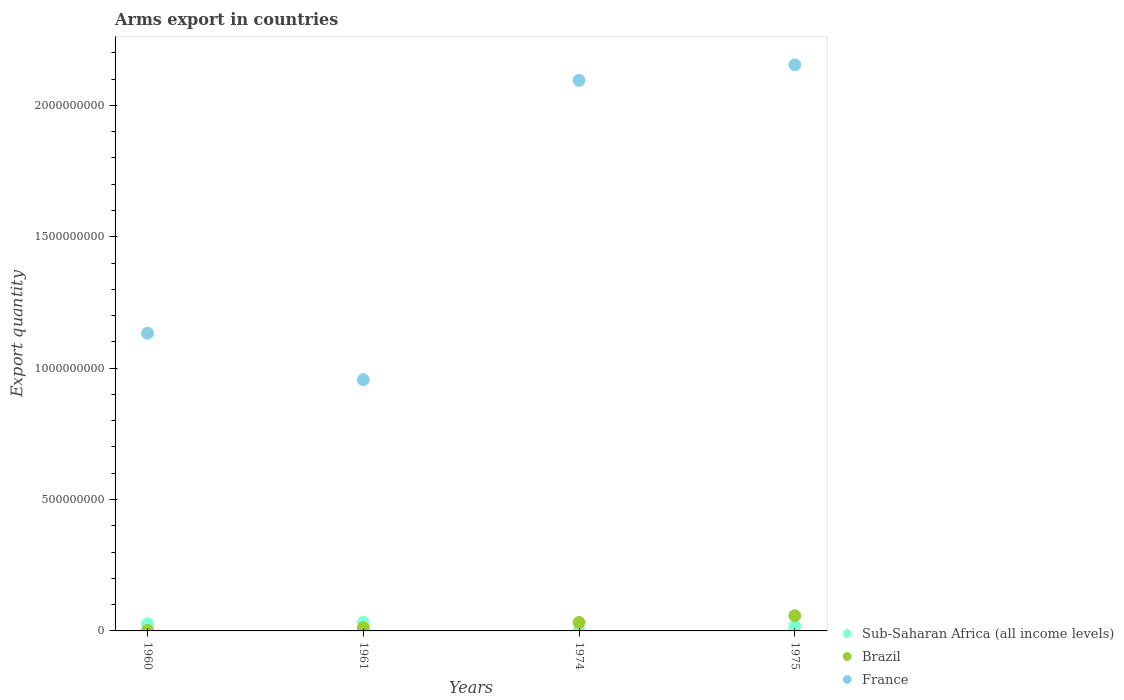How many different coloured dotlines are there?
Offer a very short reply. 3. Is the number of dotlines equal to the number of legend labels?
Keep it short and to the point. Yes. What is the total arms export in Brazil in 1974?
Your response must be concise. 3.20e+07. Across all years, what is the maximum total arms export in Sub-Saharan Africa (all income levels)?
Make the answer very short. 3.30e+07. Across all years, what is the minimum total arms export in France?
Provide a short and direct response. 9.56e+08. In which year was the total arms export in Sub-Saharan Africa (all income levels) maximum?
Your answer should be very brief. 1961. In which year was the total arms export in Sub-Saharan Africa (all income levels) minimum?
Make the answer very short. 1974. What is the total total arms export in Brazil in the graph?
Make the answer very short. 1.04e+08. What is the difference between the total arms export in France in 1960 and that in 1975?
Make the answer very short. -1.02e+09. What is the difference between the total arms export in Sub-Saharan Africa (all income levels) in 1960 and the total arms export in France in 1974?
Offer a very short reply. -2.07e+09. What is the average total arms export in France per year?
Your answer should be very brief. 1.58e+09. In the year 1974, what is the difference between the total arms export in France and total arms export in Sub-Saharan Africa (all income levels)?
Your response must be concise. 2.09e+09. In how many years, is the total arms export in Brazil greater than 500000000?
Offer a very short reply. 0. What is the ratio of the total arms export in Brazil in 1960 to that in 1974?
Give a very brief answer. 0.06. What is the difference between the highest and the second highest total arms export in Brazil?
Provide a short and direct response. 2.60e+07. What is the difference between the highest and the lowest total arms export in Sub-Saharan Africa (all income levels)?
Your answer should be compact. 3.10e+07. Is the sum of the total arms export in France in 1960 and 1961 greater than the maximum total arms export in Brazil across all years?
Provide a short and direct response. Yes. Does the total arms export in Brazil monotonically increase over the years?
Your answer should be compact. Yes. Is the total arms export in Brazil strictly greater than the total arms export in Sub-Saharan Africa (all income levels) over the years?
Your answer should be compact. No. How many dotlines are there?
Ensure brevity in your answer.  3. How many years are there in the graph?
Make the answer very short. 4. What is the difference between two consecutive major ticks on the Y-axis?
Keep it short and to the point. 5.00e+08. Does the graph contain any zero values?
Provide a succinct answer. No. Where does the legend appear in the graph?
Give a very brief answer. Bottom right. How are the legend labels stacked?
Your response must be concise. Vertical. What is the title of the graph?
Your answer should be very brief. Arms export in countries. Does "Paraguay" appear as one of the legend labels in the graph?
Keep it short and to the point. No. What is the label or title of the X-axis?
Provide a short and direct response. Years. What is the label or title of the Y-axis?
Provide a short and direct response. Export quantity. What is the Export quantity of Sub-Saharan Africa (all income levels) in 1960?
Provide a succinct answer. 2.70e+07. What is the Export quantity in Brazil in 1960?
Provide a succinct answer. 2.00e+06. What is the Export quantity of France in 1960?
Give a very brief answer. 1.13e+09. What is the Export quantity of Sub-Saharan Africa (all income levels) in 1961?
Your answer should be compact. 3.30e+07. What is the Export quantity of France in 1961?
Provide a succinct answer. 9.56e+08. What is the Export quantity of Sub-Saharan Africa (all income levels) in 1974?
Keep it short and to the point. 2.00e+06. What is the Export quantity in Brazil in 1974?
Give a very brief answer. 3.20e+07. What is the Export quantity in France in 1974?
Provide a short and direct response. 2.10e+09. What is the Export quantity of Sub-Saharan Africa (all income levels) in 1975?
Your answer should be very brief. 1.80e+07. What is the Export quantity in Brazil in 1975?
Provide a short and direct response. 5.80e+07. What is the Export quantity in France in 1975?
Your answer should be compact. 2.15e+09. Across all years, what is the maximum Export quantity in Sub-Saharan Africa (all income levels)?
Give a very brief answer. 3.30e+07. Across all years, what is the maximum Export quantity of Brazil?
Provide a short and direct response. 5.80e+07. Across all years, what is the maximum Export quantity in France?
Make the answer very short. 2.15e+09. Across all years, what is the minimum Export quantity in Sub-Saharan Africa (all income levels)?
Give a very brief answer. 2.00e+06. Across all years, what is the minimum Export quantity of Brazil?
Offer a terse response. 2.00e+06. Across all years, what is the minimum Export quantity of France?
Keep it short and to the point. 9.56e+08. What is the total Export quantity of Sub-Saharan Africa (all income levels) in the graph?
Provide a short and direct response. 8.00e+07. What is the total Export quantity of Brazil in the graph?
Your response must be concise. 1.04e+08. What is the total Export quantity of France in the graph?
Ensure brevity in your answer.  6.34e+09. What is the difference between the Export quantity in Sub-Saharan Africa (all income levels) in 1960 and that in 1961?
Your answer should be compact. -6.00e+06. What is the difference between the Export quantity in Brazil in 1960 and that in 1961?
Provide a short and direct response. -1.00e+07. What is the difference between the Export quantity of France in 1960 and that in 1961?
Your response must be concise. 1.77e+08. What is the difference between the Export quantity in Sub-Saharan Africa (all income levels) in 1960 and that in 1974?
Offer a very short reply. 2.50e+07. What is the difference between the Export quantity of Brazil in 1960 and that in 1974?
Your response must be concise. -3.00e+07. What is the difference between the Export quantity of France in 1960 and that in 1974?
Keep it short and to the point. -9.62e+08. What is the difference between the Export quantity in Sub-Saharan Africa (all income levels) in 1960 and that in 1975?
Give a very brief answer. 9.00e+06. What is the difference between the Export quantity of Brazil in 1960 and that in 1975?
Your answer should be compact. -5.60e+07. What is the difference between the Export quantity of France in 1960 and that in 1975?
Provide a succinct answer. -1.02e+09. What is the difference between the Export quantity of Sub-Saharan Africa (all income levels) in 1961 and that in 1974?
Offer a terse response. 3.10e+07. What is the difference between the Export quantity in Brazil in 1961 and that in 1974?
Your response must be concise. -2.00e+07. What is the difference between the Export quantity in France in 1961 and that in 1974?
Give a very brief answer. -1.14e+09. What is the difference between the Export quantity of Sub-Saharan Africa (all income levels) in 1961 and that in 1975?
Ensure brevity in your answer.  1.50e+07. What is the difference between the Export quantity of Brazil in 1961 and that in 1975?
Offer a very short reply. -4.60e+07. What is the difference between the Export quantity of France in 1961 and that in 1975?
Keep it short and to the point. -1.20e+09. What is the difference between the Export quantity in Sub-Saharan Africa (all income levels) in 1974 and that in 1975?
Your answer should be very brief. -1.60e+07. What is the difference between the Export quantity in Brazil in 1974 and that in 1975?
Ensure brevity in your answer.  -2.60e+07. What is the difference between the Export quantity in France in 1974 and that in 1975?
Make the answer very short. -5.90e+07. What is the difference between the Export quantity in Sub-Saharan Africa (all income levels) in 1960 and the Export quantity in Brazil in 1961?
Give a very brief answer. 1.50e+07. What is the difference between the Export quantity in Sub-Saharan Africa (all income levels) in 1960 and the Export quantity in France in 1961?
Provide a short and direct response. -9.29e+08. What is the difference between the Export quantity in Brazil in 1960 and the Export quantity in France in 1961?
Offer a very short reply. -9.54e+08. What is the difference between the Export quantity in Sub-Saharan Africa (all income levels) in 1960 and the Export quantity in Brazil in 1974?
Your answer should be compact. -5.00e+06. What is the difference between the Export quantity of Sub-Saharan Africa (all income levels) in 1960 and the Export quantity of France in 1974?
Make the answer very short. -2.07e+09. What is the difference between the Export quantity in Brazil in 1960 and the Export quantity in France in 1974?
Make the answer very short. -2.09e+09. What is the difference between the Export quantity of Sub-Saharan Africa (all income levels) in 1960 and the Export quantity of Brazil in 1975?
Provide a succinct answer. -3.10e+07. What is the difference between the Export quantity in Sub-Saharan Africa (all income levels) in 1960 and the Export quantity in France in 1975?
Keep it short and to the point. -2.13e+09. What is the difference between the Export quantity in Brazil in 1960 and the Export quantity in France in 1975?
Provide a succinct answer. -2.15e+09. What is the difference between the Export quantity in Sub-Saharan Africa (all income levels) in 1961 and the Export quantity in Brazil in 1974?
Your response must be concise. 1.00e+06. What is the difference between the Export quantity in Sub-Saharan Africa (all income levels) in 1961 and the Export quantity in France in 1974?
Ensure brevity in your answer.  -2.06e+09. What is the difference between the Export quantity of Brazil in 1961 and the Export quantity of France in 1974?
Provide a succinct answer. -2.08e+09. What is the difference between the Export quantity in Sub-Saharan Africa (all income levels) in 1961 and the Export quantity in Brazil in 1975?
Provide a succinct answer. -2.50e+07. What is the difference between the Export quantity of Sub-Saharan Africa (all income levels) in 1961 and the Export quantity of France in 1975?
Offer a terse response. -2.12e+09. What is the difference between the Export quantity in Brazil in 1961 and the Export quantity in France in 1975?
Provide a succinct answer. -2.14e+09. What is the difference between the Export quantity of Sub-Saharan Africa (all income levels) in 1974 and the Export quantity of Brazil in 1975?
Provide a short and direct response. -5.60e+07. What is the difference between the Export quantity of Sub-Saharan Africa (all income levels) in 1974 and the Export quantity of France in 1975?
Make the answer very short. -2.15e+09. What is the difference between the Export quantity in Brazil in 1974 and the Export quantity in France in 1975?
Make the answer very short. -2.12e+09. What is the average Export quantity in Brazil per year?
Your response must be concise. 2.60e+07. What is the average Export quantity in France per year?
Offer a terse response. 1.58e+09. In the year 1960, what is the difference between the Export quantity in Sub-Saharan Africa (all income levels) and Export quantity in Brazil?
Offer a terse response. 2.50e+07. In the year 1960, what is the difference between the Export quantity in Sub-Saharan Africa (all income levels) and Export quantity in France?
Your response must be concise. -1.11e+09. In the year 1960, what is the difference between the Export quantity of Brazil and Export quantity of France?
Offer a terse response. -1.13e+09. In the year 1961, what is the difference between the Export quantity of Sub-Saharan Africa (all income levels) and Export quantity of Brazil?
Offer a very short reply. 2.10e+07. In the year 1961, what is the difference between the Export quantity of Sub-Saharan Africa (all income levels) and Export quantity of France?
Your response must be concise. -9.23e+08. In the year 1961, what is the difference between the Export quantity of Brazil and Export quantity of France?
Your answer should be compact. -9.44e+08. In the year 1974, what is the difference between the Export quantity in Sub-Saharan Africa (all income levels) and Export quantity in Brazil?
Give a very brief answer. -3.00e+07. In the year 1974, what is the difference between the Export quantity of Sub-Saharan Africa (all income levels) and Export quantity of France?
Your answer should be very brief. -2.09e+09. In the year 1974, what is the difference between the Export quantity of Brazil and Export quantity of France?
Provide a short and direct response. -2.06e+09. In the year 1975, what is the difference between the Export quantity in Sub-Saharan Africa (all income levels) and Export quantity in Brazil?
Provide a short and direct response. -4.00e+07. In the year 1975, what is the difference between the Export quantity in Sub-Saharan Africa (all income levels) and Export quantity in France?
Provide a succinct answer. -2.14e+09. In the year 1975, what is the difference between the Export quantity of Brazil and Export quantity of France?
Your answer should be compact. -2.10e+09. What is the ratio of the Export quantity in Sub-Saharan Africa (all income levels) in 1960 to that in 1961?
Make the answer very short. 0.82. What is the ratio of the Export quantity in Brazil in 1960 to that in 1961?
Your answer should be compact. 0.17. What is the ratio of the Export quantity of France in 1960 to that in 1961?
Offer a terse response. 1.19. What is the ratio of the Export quantity in Sub-Saharan Africa (all income levels) in 1960 to that in 1974?
Provide a short and direct response. 13.5. What is the ratio of the Export quantity of Brazil in 1960 to that in 1974?
Provide a short and direct response. 0.06. What is the ratio of the Export quantity of France in 1960 to that in 1974?
Give a very brief answer. 0.54. What is the ratio of the Export quantity in Brazil in 1960 to that in 1975?
Your answer should be compact. 0.03. What is the ratio of the Export quantity in France in 1960 to that in 1975?
Your answer should be very brief. 0.53. What is the ratio of the Export quantity in France in 1961 to that in 1974?
Your answer should be very brief. 0.46. What is the ratio of the Export quantity of Sub-Saharan Africa (all income levels) in 1961 to that in 1975?
Make the answer very short. 1.83. What is the ratio of the Export quantity in Brazil in 1961 to that in 1975?
Your answer should be compact. 0.21. What is the ratio of the Export quantity in France in 1961 to that in 1975?
Make the answer very short. 0.44. What is the ratio of the Export quantity of Sub-Saharan Africa (all income levels) in 1974 to that in 1975?
Offer a terse response. 0.11. What is the ratio of the Export quantity in Brazil in 1974 to that in 1975?
Make the answer very short. 0.55. What is the ratio of the Export quantity in France in 1974 to that in 1975?
Ensure brevity in your answer.  0.97. What is the difference between the highest and the second highest Export quantity of Sub-Saharan Africa (all income levels)?
Provide a short and direct response. 6.00e+06. What is the difference between the highest and the second highest Export quantity of Brazil?
Your answer should be very brief. 2.60e+07. What is the difference between the highest and the second highest Export quantity in France?
Make the answer very short. 5.90e+07. What is the difference between the highest and the lowest Export quantity of Sub-Saharan Africa (all income levels)?
Provide a succinct answer. 3.10e+07. What is the difference between the highest and the lowest Export quantity of Brazil?
Give a very brief answer. 5.60e+07. What is the difference between the highest and the lowest Export quantity of France?
Offer a very short reply. 1.20e+09. 